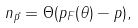Convert formula to latex. <formula><loc_0><loc_0><loc_500><loc_500>n _ { \vec { p } } = \Theta ( p _ { F } ( \theta ) - p ) ,</formula> 